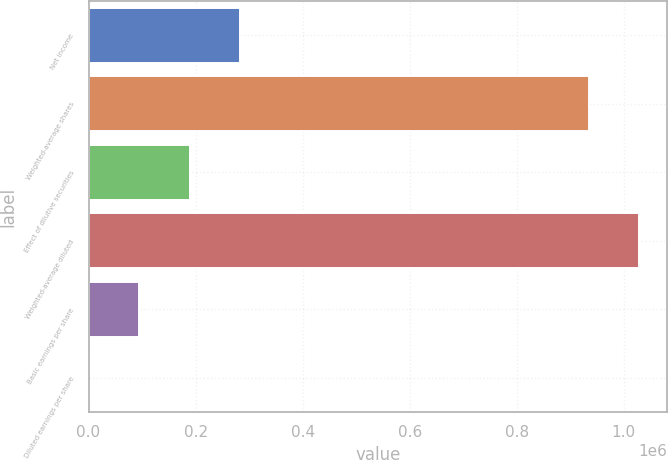Convert chart. <chart><loc_0><loc_0><loc_500><loc_500><bar_chart><fcel>Net income<fcel>Weighted-average shares<fcel>Effect of dilutive securities<fcel>Weighted-average diluted<fcel>Basic earnings per share<fcel>Diluted earnings per share<nl><fcel>283637<fcel>934818<fcel>189106<fcel>1.02935e+06<fcel>94575.2<fcel>44.15<nl></chart> 